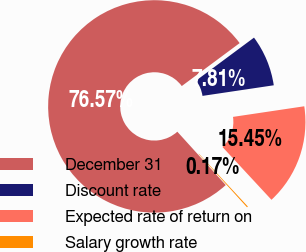Convert chart. <chart><loc_0><loc_0><loc_500><loc_500><pie_chart><fcel>December 31<fcel>Discount rate<fcel>Expected rate of return on<fcel>Salary growth rate<nl><fcel>76.57%<fcel>7.81%<fcel>15.45%<fcel>0.17%<nl></chart> 